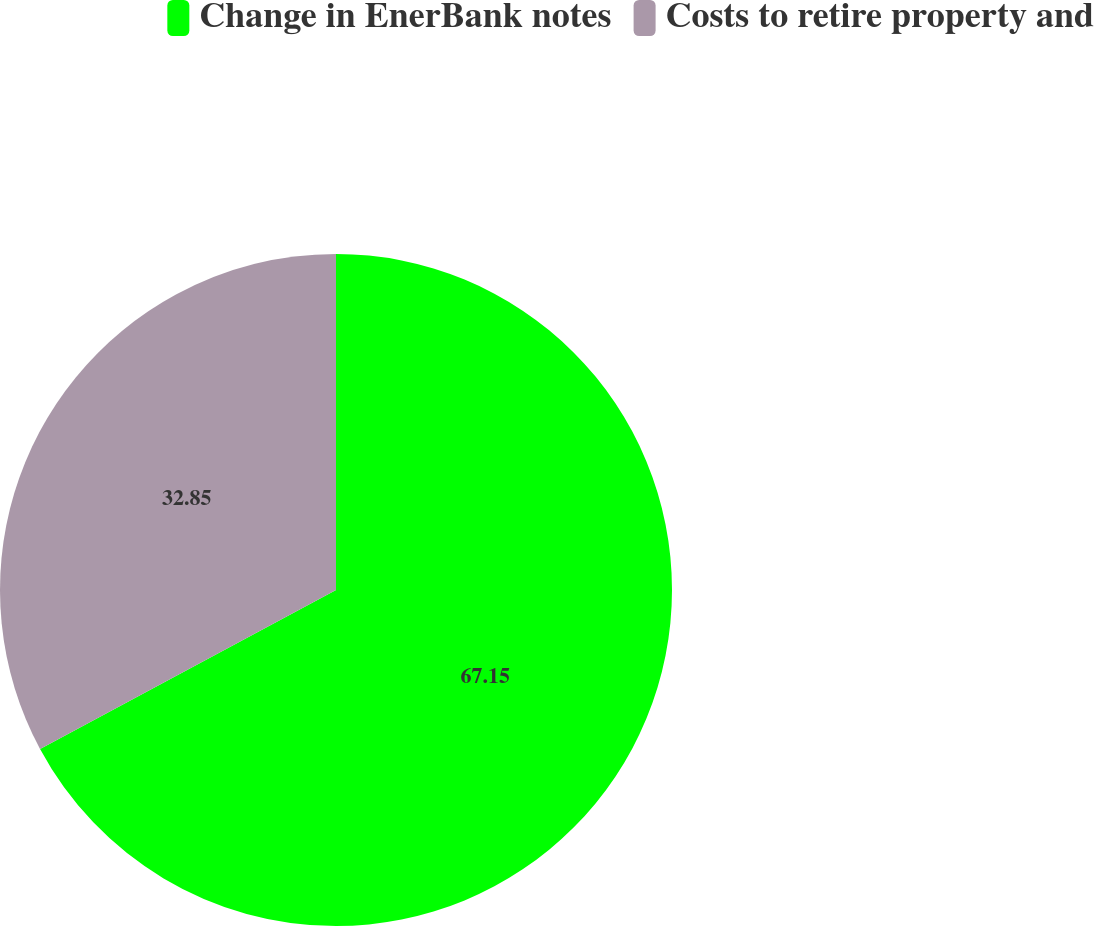Convert chart to OTSL. <chart><loc_0><loc_0><loc_500><loc_500><pie_chart><fcel>Change in EnerBank notes<fcel>Costs to retire property and<nl><fcel>67.15%<fcel>32.85%<nl></chart> 